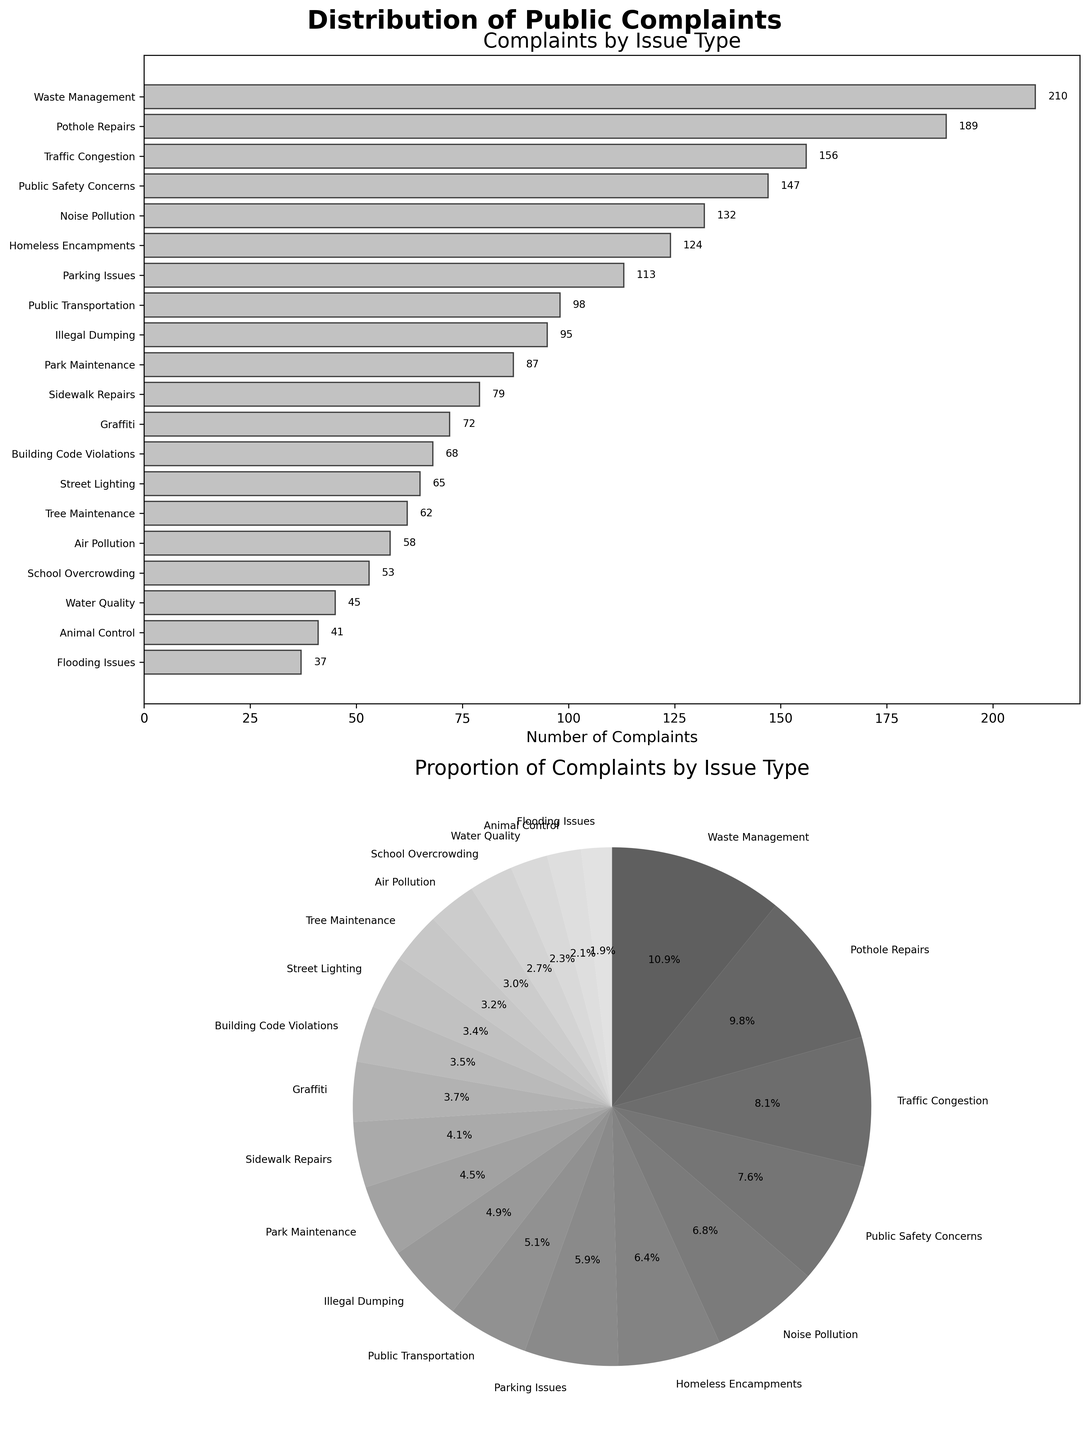How many more complaints are related to Waste Management compared to Sidewalk Repairs? Waste Management has 210 complaints, and Sidewalk Repairs have 79. The difference is: 210 - 79 = 131
Answer: 131 Which issue received the fewest complaints? By looking at the bar chart, Flooding Issues received the fewest complaints with 37.
Answer: Flooding Issues What percentage of the total complaints is related to Traffic Congestion? The total number of complaints is the sum of all individual complaints: 156 + 132 + 210 + 98 + 87 + 65 + 113 + 79 + 45 + 58 + 124 + 72 + 189 + 53 + 41 + 68 + 95 + 147 + 37 + 62 = 1831. Traffic Congestion complaints are 156. The percentage is (156 / 1831) * 100 ≈ 8.5%
Answer: 8.5% Are there more complaints about Noise Pollution or Graffiti? By observing the bar chart, Noise Pollution received 132 complaints, while Graffiti received 72. Noise Pollution has more complaints.
Answer: Noise Pollution What is the combined number of complaints for Pothole Repairs and Street Lighting? Pothole Repairs has 189 complaints and Street Lighting has 65. Adding them up: 189 + 65 = 254
Answer: 254 How many complaint types received fewer than 50 complaints? By scanning the bar chart, Water Quality (45), School Overcrowding (53), Animal Control (41), Flooding Issues (37), and Tree Maintenance (62) are visible. Only Water Quality, Animal Control, and Flooding Issues received fewer than 50 complaints.
Answer: 3 Which issue type received the second-highest number of complaints? By looking at the sorted bar chart, Waste Management received the highest (210). The second-highest is Pothole Repairs with 189 complaints.
Answer: Pothole Repairs What is the cumulative percentage of complaints for the top three most complained issues? The top three most complained issues are Waste Management (210), Pothole Repairs (189), and Traffic Congestion (156). Their total is 210 + 189 + 156 = 555. The total number of complaints is 1831. The cumulative percentage is (555 / 1831) * 100 ≈ 30.3%
Answer: 30.3% How does the number of complaints related to Public Safety Concerns compare to those related to Homeless Encampments? Public Safety Concerns have 147 complaints, and Homeless Encampments have 124. Comparing them shows that Public Safety Concerns have more complaints.
Answer: Public Safety Concerns Which issue type received the most complaints, and what proportion does it represent in the pie chart? Waste Management received the most complaints (210). The total number of complaints is 1831. The proportion is (210 / 1831) * 100 ≈ 11.5%.
Answer: Waste Management, 11.5% 